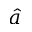Convert formula to latex. <formula><loc_0><loc_0><loc_500><loc_500>\hat { a }</formula> 